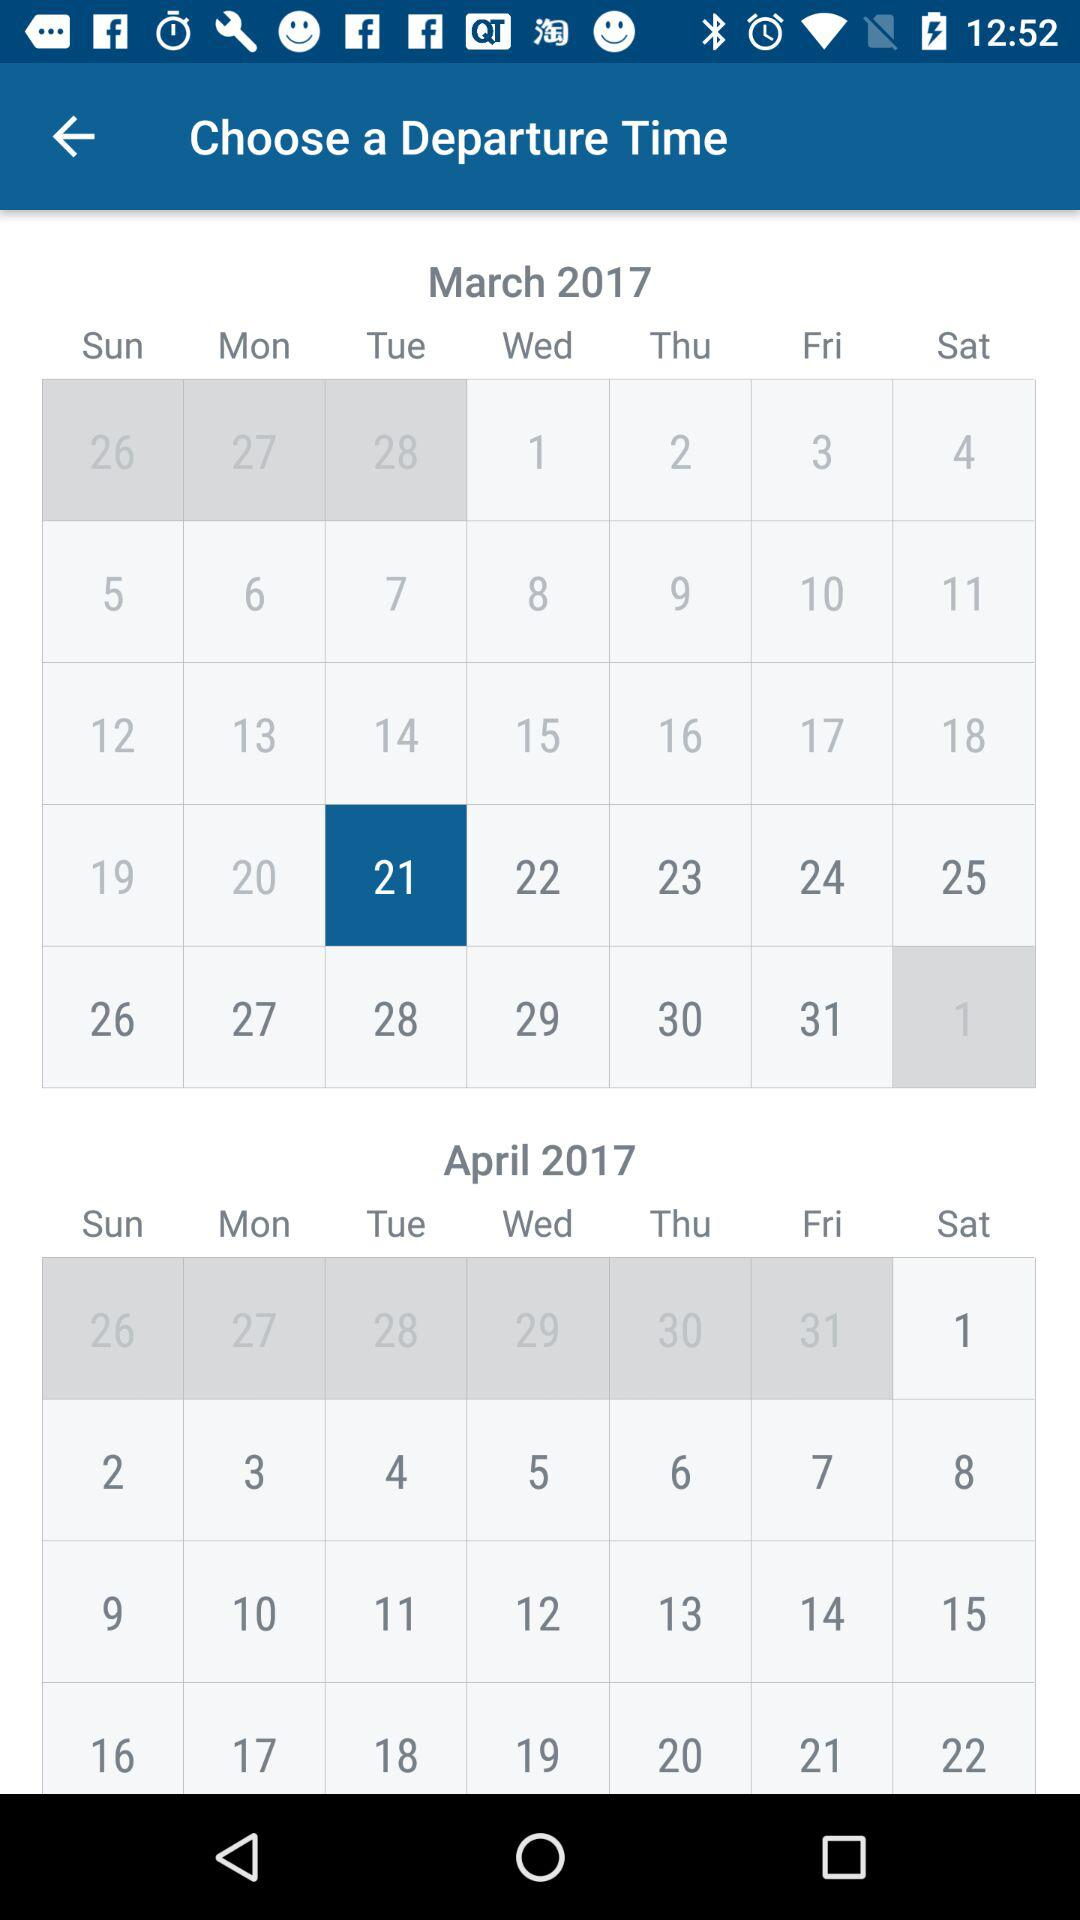What day is 21st of March? The day is Tuesday. 